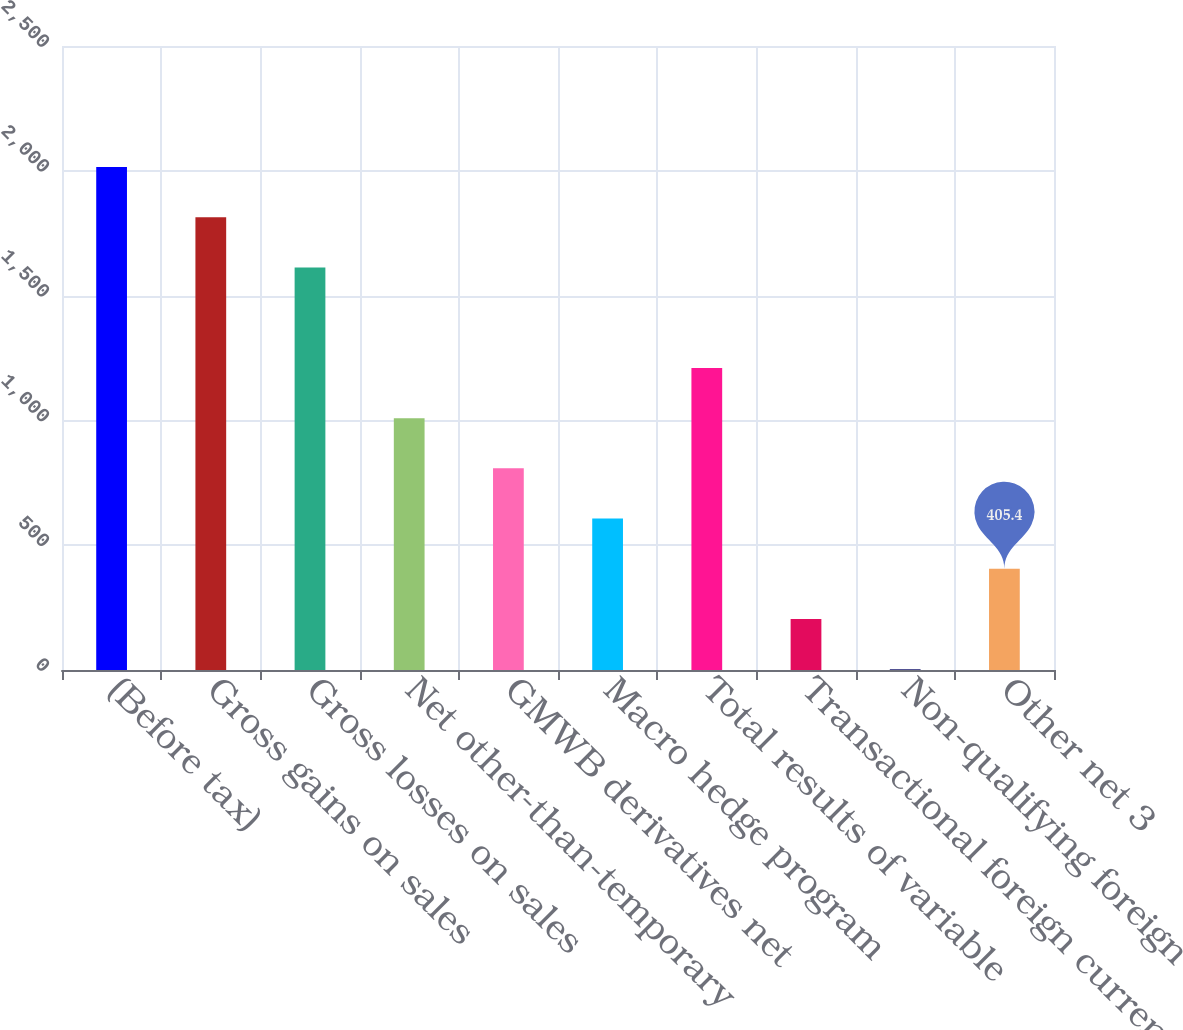Convert chart to OTSL. <chart><loc_0><loc_0><loc_500><loc_500><bar_chart><fcel>(Before tax)<fcel>Gross gains on sales<fcel>Gross losses on sales<fcel>Net other-than-temporary<fcel>GMWB derivatives net<fcel>Macro hedge program<fcel>Total results of variable<fcel>Transactional foreign currency<fcel>Non-qualifying foreign<fcel>Other net 3<nl><fcel>2015<fcel>1813.8<fcel>1612.6<fcel>1009<fcel>807.8<fcel>606.6<fcel>1210.2<fcel>204.2<fcel>3<fcel>405.4<nl></chart> 